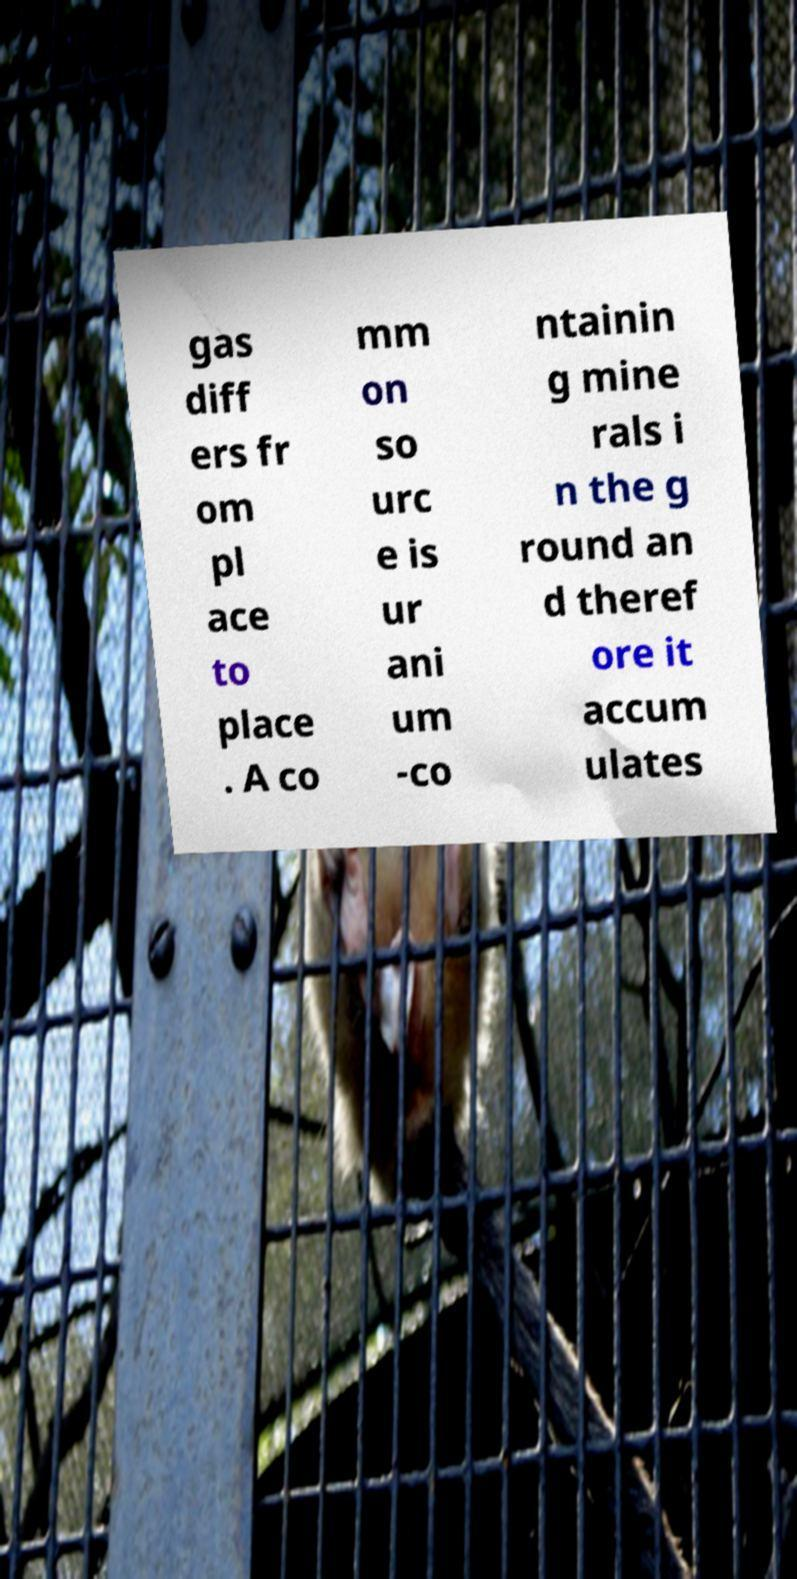There's text embedded in this image that I need extracted. Can you transcribe it verbatim? gas diff ers fr om pl ace to place . A co mm on so urc e is ur ani um -co ntainin g mine rals i n the g round an d theref ore it accum ulates 